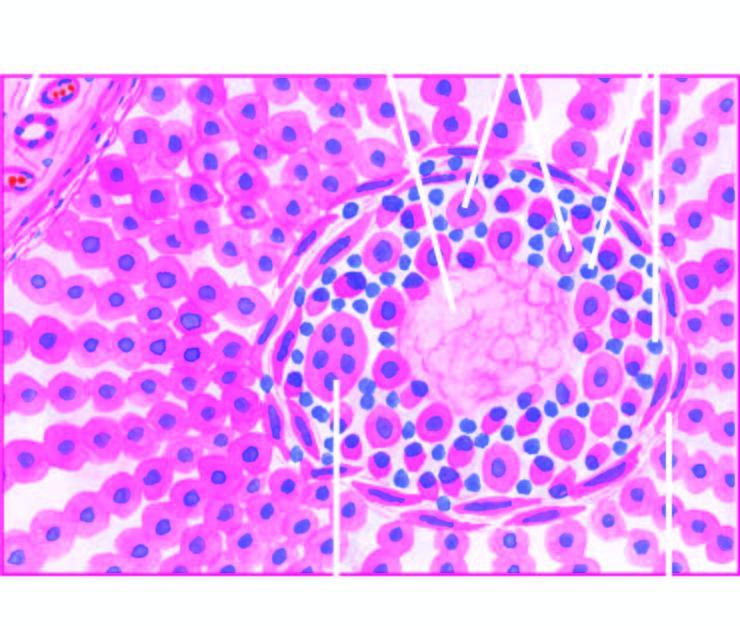s adp surrounded by palisades of macrophages and plasma cells marginated peripherally by fibroblasts?
Answer the question using a single word or phrase. No 